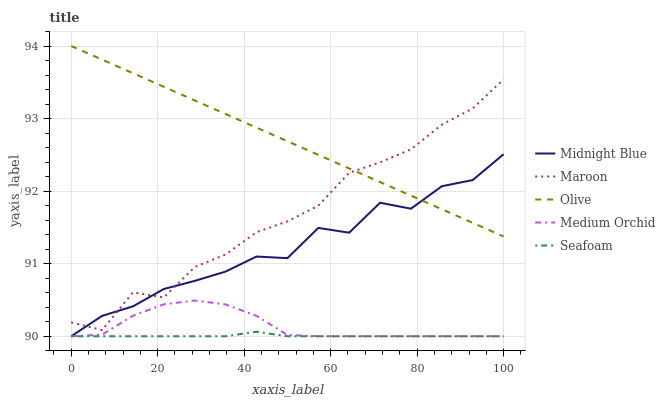Does Seafoam have the minimum area under the curve?
Answer yes or no. Yes. Does Olive have the maximum area under the curve?
Answer yes or no. Yes. Does Medium Orchid have the minimum area under the curve?
Answer yes or no. No. Does Medium Orchid have the maximum area under the curve?
Answer yes or no. No. Is Olive the smoothest?
Answer yes or no. Yes. Is Midnight Blue the roughest?
Answer yes or no. Yes. Is Medium Orchid the smoothest?
Answer yes or no. No. Is Medium Orchid the roughest?
Answer yes or no. No. Does Maroon have the lowest value?
Answer yes or no. No. Does Olive have the highest value?
Answer yes or no. Yes. Does Medium Orchid have the highest value?
Answer yes or no. No. Is Seafoam less than Olive?
Answer yes or no. Yes. Is Olive greater than Seafoam?
Answer yes or no. Yes. Does Olive intersect Midnight Blue?
Answer yes or no. Yes. Is Olive less than Midnight Blue?
Answer yes or no. No. Is Olive greater than Midnight Blue?
Answer yes or no. No. Does Seafoam intersect Olive?
Answer yes or no. No. 